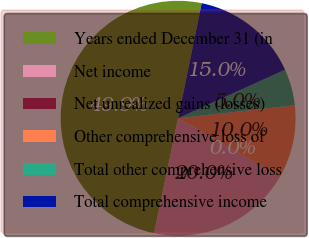<chart> <loc_0><loc_0><loc_500><loc_500><pie_chart><fcel>Years ended December 31 (in<fcel>Net income<fcel>Net unrealized gains (losses)<fcel>Other comprehensive loss of<fcel>Total other comprehensive loss<fcel>Total comprehensive income<nl><fcel>49.94%<fcel>19.99%<fcel>0.03%<fcel>10.01%<fcel>5.02%<fcel>15.0%<nl></chart> 